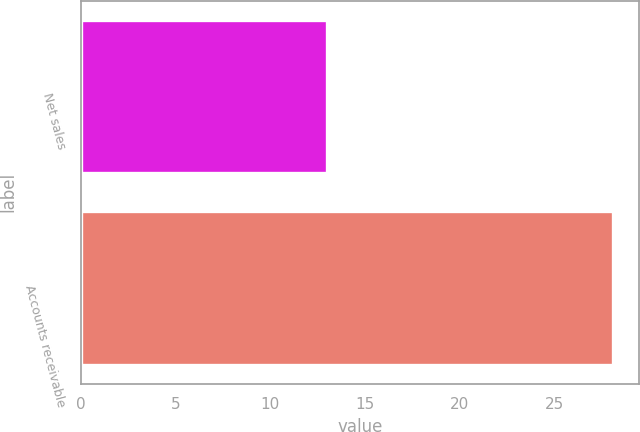<chart> <loc_0><loc_0><loc_500><loc_500><bar_chart><fcel>Net sales<fcel>Accounts receivable<nl><fcel>13<fcel>28.1<nl></chart> 